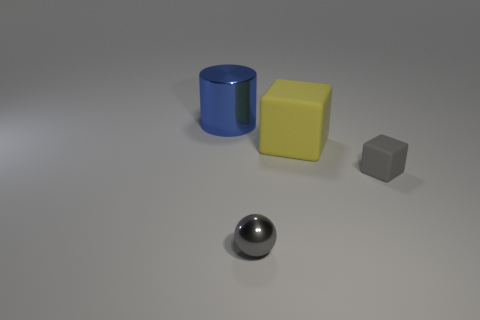What shape is the small matte thing that is the same color as the tiny metal object?
Keep it short and to the point. Cube. What is the size of the metal thing that is in front of the blue metallic object that is to the left of the big thing to the right of the large blue metallic thing?
Your response must be concise. Small. What is the large yellow thing made of?
Offer a very short reply. Rubber. Is the large yellow object made of the same material as the gray object that is right of the tiny shiny sphere?
Your answer should be very brief. Yes. Is there any other thing of the same color as the metallic cylinder?
Ensure brevity in your answer.  No. There is a tiny gray object behind the metallic object that is right of the big blue cylinder; are there any tiny metallic objects to the right of it?
Offer a terse response. No. What color is the small rubber block?
Your answer should be compact. Gray. Are there any small things in front of the small gray metal sphere?
Offer a terse response. No. Do the big blue thing and the big object in front of the blue thing have the same shape?
Keep it short and to the point. No. What number of other objects are there of the same material as the tiny gray block?
Your answer should be very brief. 1. 